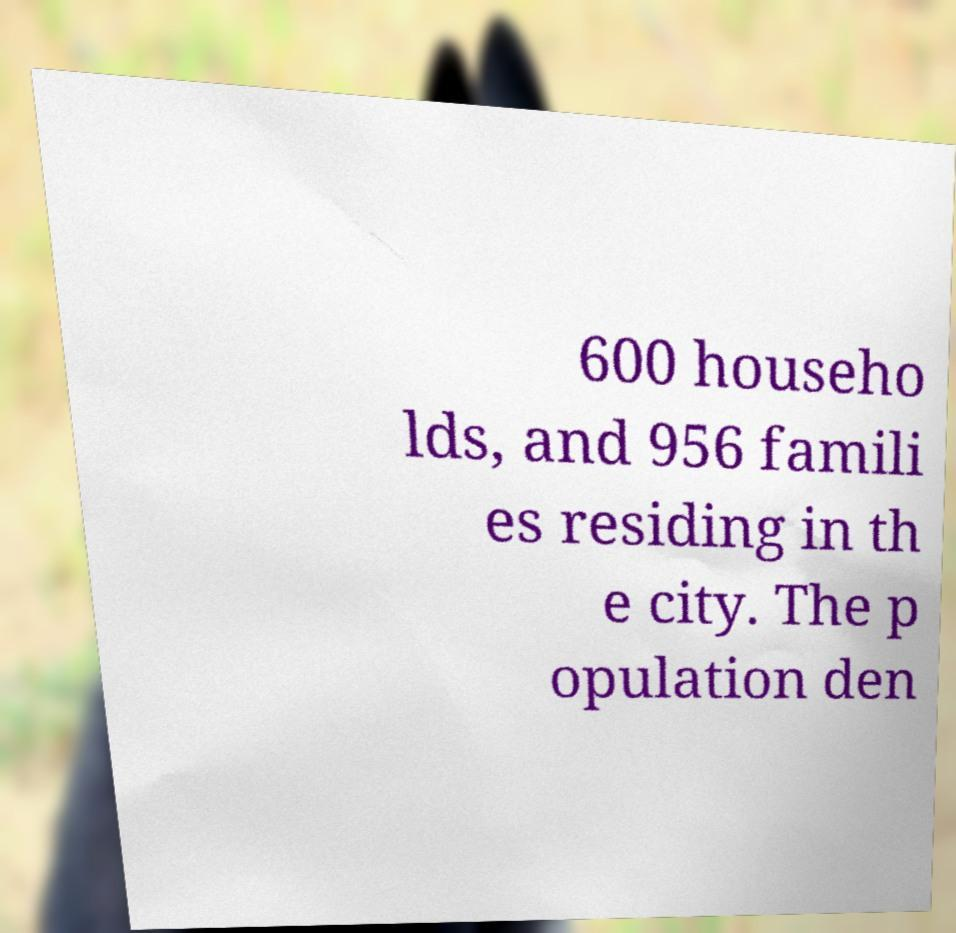I need the written content from this picture converted into text. Can you do that? 600 househo lds, and 956 famili es residing in th e city. The p opulation den 